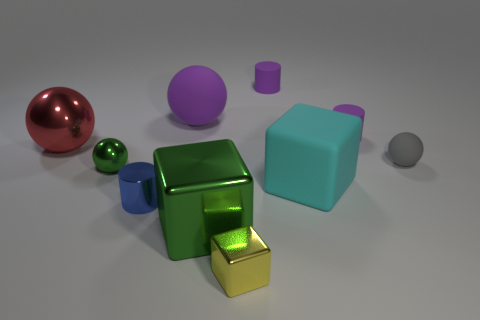Subtract all balls. How many objects are left? 6 Subtract all purple matte cylinders. Subtract all large objects. How many objects are left? 4 Add 3 metal objects. How many metal objects are left? 8 Add 6 small cyan rubber objects. How many small cyan rubber objects exist? 6 Subtract 0 purple cubes. How many objects are left? 10 